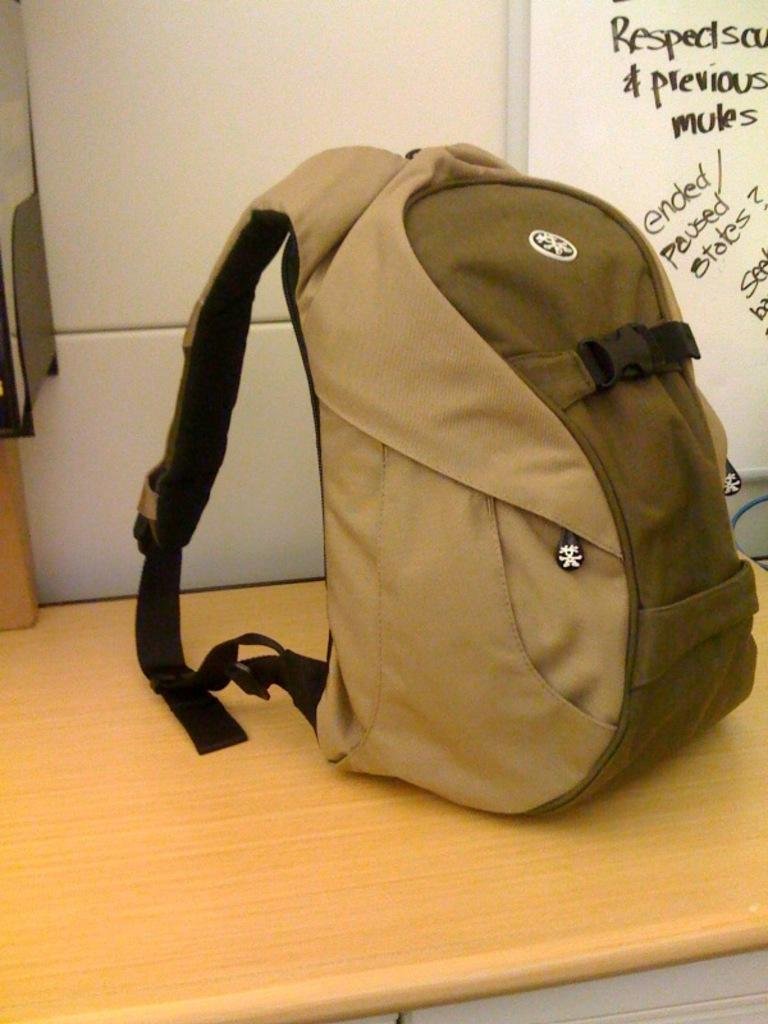<image>
Create a compact narrative representing the image presented. a brown backpack in front of a white board with words ended, paused on it 